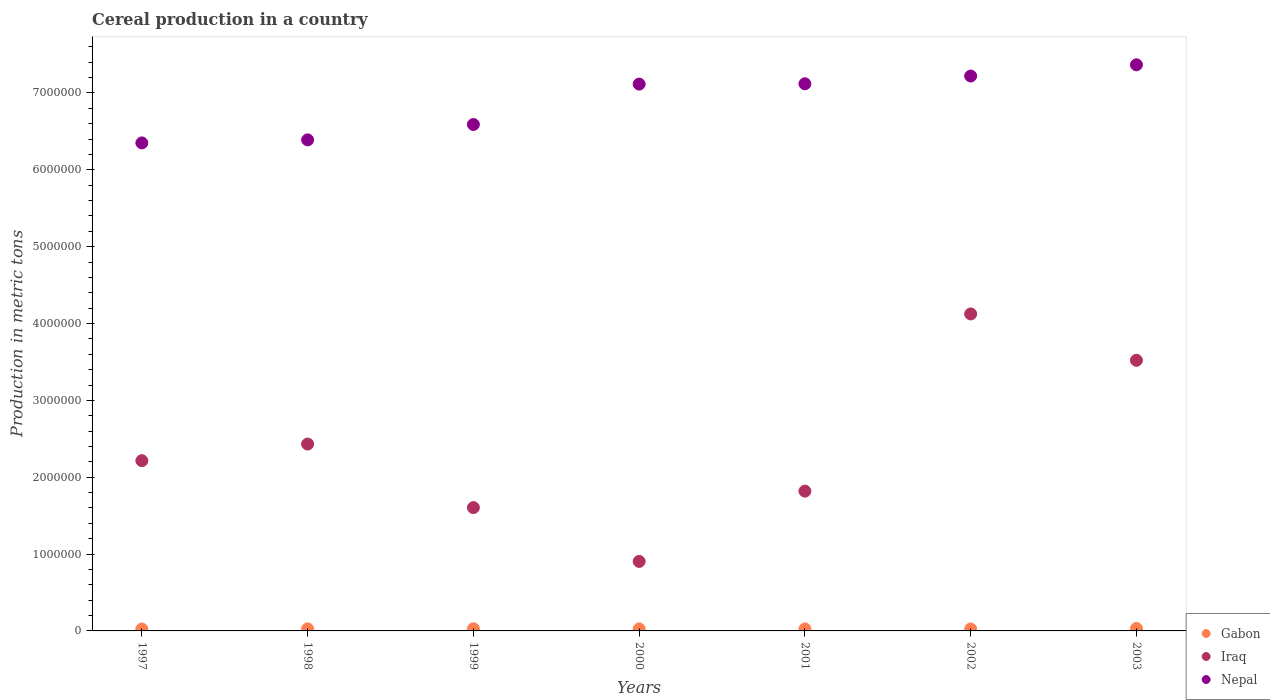Is the number of dotlines equal to the number of legend labels?
Make the answer very short. Yes. What is the total cereal production in Gabon in 2001?
Offer a very short reply. 2.61e+04. Across all years, what is the maximum total cereal production in Gabon?
Offer a very short reply. 3.22e+04. Across all years, what is the minimum total cereal production in Gabon?
Keep it short and to the point. 2.46e+04. In which year was the total cereal production in Nepal maximum?
Your response must be concise. 2003. In which year was the total cereal production in Iraq minimum?
Give a very brief answer. 2000. What is the total total cereal production in Iraq in the graph?
Make the answer very short. 1.66e+07. What is the difference between the total cereal production in Gabon in 2000 and that in 2002?
Offer a terse response. 1973. What is the difference between the total cereal production in Gabon in 2002 and the total cereal production in Nepal in 2001?
Provide a short and direct response. -7.10e+06. What is the average total cereal production in Gabon per year?
Ensure brevity in your answer.  2.70e+04. In the year 1998, what is the difference between the total cereal production in Gabon and total cereal production in Iraq?
Give a very brief answer. -2.40e+06. What is the ratio of the total cereal production in Nepal in 1999 to that in 2000?
Keep it short and to the point. 0.93. What is the difference between the highest and the second highest total cereal production in Nepal?
Ensure brevity in your answer.  1.46e+05. What is the difference between the highest and the lowest total cereal production in Nepal?
Your answer should be compact. 1.02e+06. Is the sum of the total cereal production in Nepal in 1997 and 2001 greater than the maximum total cereal production in Iraq across all years?
Make the answer very short. Yes. Is the total cereal production in Nepal strictly less than the total cereal production in Iraq over the years?
Provide a succinct answer. No. How many dotlines are there?
Offer a very short reply. 3. Are the values on the major ticks of Y-axis written in scientific E-notation?
Provide a succinct answer. No. Does the graph contain any zero values?
Offer a very short reply. No. How many legend labels are there?
Ensure brevity in your answer.  3. What is the title of the graph?
Offer a very short reply. Cereal production in a country. What is the label or title of the Y-axis?
Provide a short and direct response. Production in metric tons. What is the Production in metric tons of Gabon in 1997?
Ensure brevity in your answer.  2.46e+04. What is the Production in metric tons of Iraq in 1997?
Your answer should be very brief. 2.22e+06. What is the Production in metric tons of Nepal in 1997?
Offer a terse response. 6.35e+06. What is the Production in metric tons in Gabon in 1998?
Keep it short and to the point. 2.69e+04. What is the Production in metric tons in Iraq in 1998?
Make the answer very short. 2.43e+06. What is the Production in metric tons in Nepal in 1998?
Provide a succinct answer. 6.39e+06. What is the Production in metric tons in Gabon in 1999?
Offer a very short reply. 2.75e+04. What is the Production in metric tons of Iraq in 1999?
Your response must be concise. 1.60e+06. What is the Production in metric tons of Nepal in 1999?
Your answer should be very brief. 6.59e+06. What is the Production in metric tons in Gabon in 2000?
Your answer should be compact. 2.69e+04. What is the Production in metric tons of Iraq in 2000?
Your answer should be compact. 9.04e+05. What is the Production in metric tons in Nepal in 2000?
Provide a succinct answer. 7.12e+06. What is the Production in metric tons in Gabon in 2001?
Offer a terse response. 2.61e+04. What is the Production in metric tons in Iraq in 2001?
Provide a short and direct response. 1.82e+06. What is the Production in metric tons in Nepal in 2001?
Your response must be concise. 7.12e+06. What is the Production in metric tons in Gabon in 2002?
Keep it short and to the point. 2.49e+04. What is the Production in metric tons in Iraq in 2002?
Give a very brief answer. 4.12e+06. What is the Production in metric tons of Nepal in 2002?
Provide a short and direct response. 7.22e+06. What is the Production in metric tons in Gabon in 2003?
Offer a terse response. 3.22e+04. What is the Production in metric tons in Iraq in 2003?
Provide a short and direct response. 3.52e+06. What is the Production in metric tons of Nepal in 2003?
Make the answer very short. 7.37e+06. Across all years, what is the maximum Production in metric tons in Gabon?
Make the answer very short. 3.22e+04. Across all years, what is the maximum Production in metric tons of Iraq?
Ensure brevity in your answer.  4.12e+06. Across all years, what is the maximum Production in metric tons of Nepal?
Offer a terse response. 7.37e+06. Across all years, what is the minimum Production in metric tons in Gabon?
Offer a terse response. 2.46e+04. Across all years, what is the minimum Production in metric tons in Iraq?
Make the answer very short. 9.04e+05. Across all years, what is the minimum Production in metric tons of Nepal?
Make the answer very short. 6.35e+06. What is the total Production in metric tons in Gabon in the graph?
Offer a very short reply. 1.89e+05. What is the total Production in metric tons of Iraq in the graph?
Your response must be concise. 1.66e+07. What is the total Production in metric tons in Nepal in the graph?
Keep it short and to the point. 4.82e+07. What is the difference between the Production in metric tons of Gabon in 1997 and that in 1998?
Offer a terse response. -2259. What is the difference between the Production in metric tons of Iraq in 1997 and that in 1998?
Ensure brevity in your answer.  -2.16e+05. What is the difference between the Production in metric tons of Nepal in 1997 and that in 1998?
Keep it short and to the point. -3.96e+04. What is the difference between the Production in metric tons in Gabon in 1997 and that in 1999?
Provide a short and direct response. -2875. What is the difference between the Production in metric tons of Iraq in 1997 and that in 1999?
Your answer should be compact. 6.11e+05. What is the difference between the Production in metric tons of Nepal in 1997 and that in 1999?
Your answer should be compact. -2.40e+05. What is the difference between the Production in metric tons of Gabon in 1997 and that in 2000?
Your answer should be compact. -2254. What is the difference between the Production in metric tons in Iraq in 1997 and that in 2000?
Give a very brief answer. 1.31e+06. What is the difference between the Production in metric tons in Nepal in 1997 and that in 2000?
Make the answer very short. -7.65e+05. What is the difference between the Production in metric tons in Gabon in 1997 and that in 2001?
Provide a short and direct response. -1475. What is the difference between the Production in metric tons in Iraq in 1997 and that in 2001?
Your answer should be compact. 3.97e+05. What is the difference between the Production in metric tons of Nepal in 1997 and that in 2001?
Ensure brevity in your answer.  -7.70e+05. What is the difference between the Production in metric tons of Gabon in 1997 and that in 2002?
Make the answer very short. -281. What is the difference between the Production in metric tons of Iraq in 1997 and that in 2002?
Your answer should be compact. -1.91e+06. What is the difference between the Production in metric tons of Nepal in 1997 and that in 2002?
Provide a succinct answer. -8.70e+05. What is the difference between the Production in metric tons in Gabon in 1997 and that in 2003?
Ensure brevity in your answer.  -7551. What is the difference between the Production in metric tons of Iraq in 1997 and that in 2003?
Your answer should be very brief. -1.31e+06. What is the difference between the Production in metric tons of Nepal in 1997 and that in 2003?
Ensure brevity in your answer.  -1.02e+06. What is the difference between the Production in metric tons of Gabon in 1998 and that in 1999?
Offer a terse response. -616. What is the difference between the Production in metric tons of Iraq in 1998 and that in 1999?
Offer a terse response. 8.27e+05. What is the difference between the Production in metric tons in Nepal in 1998 and that in 1999?
Keep it short and to the point. -2.00e+05. What is the difference between the Production in metric tons in Iraq in 1998 and that in 2000?
Ensure brevity in your answer.  1.53e+06. What is the difference between the Production in metric tons in Nepal in 1998 and that in 2000?
Offer a very short reply. -7.26e+05. What is the difference between the Production in metric tons of Gabon in 1998 and that in 2001?
Provide a succinct answer. 784. What is the difference between the Production in metric tons in Iraq in 1998 and that in 2001?
Ensure brevity in your answer.  6.13e+05. What is the difference between the Production in metric tons of Nepal in 1998 and that in 2001?
Provide a short and direct response. -7.30e+05. What is the difference between the Production in metric tons in Gabon in 1998 and that in 2002?
Ensure brevity in your answer.  1978. What is the difference between the Production in metric tons of Iraq in 1998 and that in 2002?
Offer a very short reply. -1.69e+06. What is the difference between the Production in metric tons in Nepal in 1998 and that in 2002?
Keep it short and to the point. -8.31e+05. What is the difference between the Production in metric tons in Gabon in 1998 and that in 2003?
Offer a very short reply. -5292. What is the difference between the Production in metric tons of Iraq in 1998 and that in 2003?
Ensure brevity in your answer.  -1.09e+06. What is the difference between the Production in metric tons in Nepal in 1998 and that in 2003?
Provide a succinct answer. -9.77e+05. What is the difference between the Production in metric tons in Gabon in 1999 and that in 2000?
Provide a short and direct response. 621. What is the difference between the Production in metric tons in Iraq in 1999 and that in 2000?
Your response must be concise. 7.00e+05. What is the difference between the Production in metric tons of Nepal in 1999 and that in 2000?
Your answer should be compact. -5.26e+05. What is the difference between the Production in metric tons of Gabon in 1999 and that in 2001?
Ensure brevity in your answer.  1400. What is the difference between the Production in metric tons of Iraq in 1999 and that in 2001?
Offer a terse response. -2.14e+05. What is the difference between the Production in metric tons in Nepal in 1999 and that in 2001?
Ensure brevity in your answer.  -5.30e+05. What is the difference between the Production in metric tons of Gabon in 1999 and that in 2002?
Your answer should be compact. 2594. What is the difference between the Production in metric tons in Iraq in 1999 and that in 2002?
Your response must be concise. -2.52e+06. What is the difference between the Production in metric tons of Nepal in 1999 and that in 2002?
Your response must be concise. -6.31e+05. What is the difference between the Production in metric tons in Gabon in 1999 and that in 2003?
Your answer should be very brief. -4676. What is the difference between the Production in metric tons of Iraq in 1999 and that in 2003?
Make the answer very short. -1.92e+06. What is the difference between the Production in metric tons of Nepal in 1999 and that in 2003?
Keep it short and to the point. -7.77e+05. What is the difference between the Production in metric tons in Gabon in 2000 and that in 2001?
Provide a short and direct response. 779. What is the difference between the Production in metric tons of Iraq in 2000 and that in 2001?
Offer a very short reply. -9.15e+05. What is the difference between the Production in metric tons of Nepal in 2000 and that in 2001?
Your response must be concise. -4417. What is the difference between the Production in metric tons of Gabon in 2000 and that in 2002?
Ensure brevity in your answer.  1973. What is the difference between the Production in metric tons of Iraq in 2000 and that in 2002?
Offer a very short reply. -3.22e+06. What is the difference between the Production in metric tons in Nepal in 2000 and that in 2002?
Provide a succinct answer. -1.05e+05. What is the difference between the Production in metric tons of Gabon in 2000 and that in 2003?
Offer a terse response. -5297. What is the difference between the Production in metric tons of Iraq in 2000 and that in 2003?
Ensure brevity in your answer.  -2.62e+06. What is the difference between the Production in metric tons in Nepal in 2000 and that in 2003?
Your response must be concise. -2.51e+05. What is the difference between the Production in metric tons of Gabon in 2001 and that in 2002?
Make the answer very short. 1194. What is the difference between the Production in metric tons in Iraq in 2001 and that in 2002?
Ensure brevity in your answer.  -2.31e+06. What is the difference between the Production in metric tons in Nepal in 2001 and that in 2002?
Your response must be concise. -1.01e+05. What is the difference between the Production in metric tons in Gabon in 2001 and that in 2003?
Offer a very short reply. -6076. What is the difference between the Production in metric tons in Iraq in 2001 and that in 2003?
Offer a terse response. -1.70e+06. What is the difference between the Production in metric tons in Nepal in 2001 and that in 2003?
Provide a succinct answer. -2.47e+05. What is the difference between the Production in metric tons in Gabon in 2002 and that in 2003?
Give a very brief answer. -7270. What is the difference between the Production in metric tons of Iraq in 2002 and that in 2003?
Offer a terse response. 6.04e+05. What is the difference between the Production in metric tons in Nepal in 2002 and that in 2003?
Keep it short and to the point. -1.46e+05. What is the difference between the Production in metric tons in Gabon in 1997 and the Production in metric tons in Iraq in 1998?
Your answer should be compact. -2.41e+06. What is the difference between the Production in metric tons in Gabon in 1997 and the Production in metric tons in Nepal in 1998?
Give a very brief answer. -6.37e+06. What is the difference between the Production in metric tons in Iraq in 1997 and the Production in metric tons in Nepal in 1998?
Provide a short and direct response. -4.17e+06. What is the difference between the Production in metric tons in Gabon in 1997 and the Production in metric tons in Iraq in 1999?
Make the answer very short. -1.58e+06. What is the difference between the Production in metric tons of Gabon in 1997 and the Production in metric tons of Nepal in 1999?
Your answer should be very brief. -6.57e+06. What is the difference between the Production in metric tons of Iraq in 1997 and the Production in metric tons of Nepal in 1999?
Offer a very short reply. -4.37e+06. What is the difference between the Production in metric tons of Gabon in 1997 and the Production in metric tons of Iraq in 2000?
Offer a very short reply. -8.80e+05. What is the difference between the Production in metric tons in Gabon in 1997 and the Production in metric tons in Nepal in 2000?
Make the answer very short. -7.09e+06. What is the difference between the Production in metric tons in Iraq in 1997 and the Production in metric tons in Nepal in 2000?
Provide a succinct answer. -4.90e+06. What is the difference between the Production in metric tons in Gabon in 1997 and the Production in metric tons in Iraq in 2001?
Your response must be concise. -1.79e+06. What is the difference between the Production in metric tons in Gabon in 1997 and the Production in metric tons in Nepal in 2001?
Ensure brevity in your answer.  -7.10e+06. What is the difference between the Production in metric tons of Iraq in 1997 and the Production in metric tons of Nepal in 2001?
Your response must be concise. -4.90e+06. What is the difference between the Production in metric tons in Gabon in 1997 and the Production in metric tons in Iraq in 2002?
Provide a short and direct response. -4.10e+06. What is the difference between the Production in metric tons in Gabon in 1997 and the Production in metric tons in Nepal in 2002?
Give a very brief answer. -7.20e+06. What is the difference between the Production in metric tons in Iraq in 1997 and the Production in metric tons in Nepal in 2002?
Offer a terse response. -5.01e+06. What is the difference between the Production in metric tons in Gabon in 1997 and the Production in metric tons in Iraq in 2003?
Ensure brevity in your answer.  -3.50e+06. What is the difference between the Production in metric tons of Gabon in 1997 and the Production in metric tons of Nepal in 2003?
Offer a very short reply. -7.34e+06. What is the difference between the Production in metric tons in Iraq in 1997 and the Production in metric tons in Nepal in 2003?
Provide a short and direct response. -5.15e+06. What is the difference between the Production in metric tons of Gabon in 1998 and the Production in metric tons of Iraq in 1999?
Ensure brevity in your answer.  -1.58e+06. What is the difference between the Production in metric tons of Gabon in 1998 and the Production in metric tons of Nepal in 1999?
Provide a succinct answer. -6.56e+06. What is the difference between the Production in metric tons of Iraq in 1998 and the Production in metric tons of Nepal in 1999?
Your answer should be very brief. -4.16e+06. What is the difference between the Production in metric tons of Gabon in 1998 and the Production in metric tons of Iraq in 2000?
Your answer should be very brief. -8.78e+05. What is the difference between the Production in metric tons of Gabon in 1998 and the Production in metric tons of Nepal in 2000?
Give a very brief answer. -7.09e+06. What is the difference between the Production in metric tons of Iraq in 1998 and the Production in metric tons of Nepal in 2000?
Give a very brief answer. -4.68e+06. What is the difference between the Production in metric tons of Gabon in 1998 and the Production in metric tons of Iraq in 2001?
Keep it short and to the point. -1.79e+06. What is the difference between the Production in metric tons in Gabon in 1998 and the Production in metric tons in Nepal in 2001?
Offer a terse response. -7.09e+06. What is the difference between the Production in metric tons of Iraq in 1998 and the Production in metric tons of Nepal in 2001?
Provide a short and direct response. -4.69e+06. What is the difference between the Production in metric tons of Gabon in 1998 and the Production in metric tons of Iraq in 2002?
Provide a short and direct response. -4.10e+06. What is the difference between the Production in metric tons in Gabon in 1998 and the Production in metric tons in Nepal in 2002?
Your answer should be compact. -7.19e+06. What is the difference between the Production in metric tons of Iraq in 1998 and the Production in metric tons of Nepal in 2002?
Provide a short and direct response. -4.79e+06. What is the difference between the Production in metric tons in Gabon in 1998 and the Production in metric tons in Iraq in 2003?
Make the answer very short. -3.49e+06. What is the difference between the Production in metric tons in Gabon in 1998 and the Production in metric tons in Nepal in 2003?
Your response must be concise. -7.34e+06. What is the difference between the Production in metric tons in Iraq in 1998 and the Production in metric tons in Nepal in 2003?
Provide a short and direct response. -4.94e+06. What is the difference between the Production in metric tons in Gabon in 1999 and the Production in metric tons in Iraq in 2000?
Make the answer very short. -8.77e+05. What is the difference between the Production in metric tons of Gabon in 1999 and the Production in metric tons of Nepal in 2000?
Your answer should be compact. -7.09e+06. What is the difference between the Production in metric tons of Iraq in 1999 and the Production in metric tons of Nepal in 2000?
Give a very brief answer. -5.51e+06. What is the difference between the Production in metric tons in Gabon in 1999 and the Production in metric tons in Iraq in 2001?
Ensure brevity in your answer.  -1.79e+06. What is the difference between the Production in metric tons of Gabon in 1999 and the Production in metric tons of Nepal in 2001?
Provide a short and direct response. -7.09e+06. What is the difference between the Production in metric tons of Iraq in 1999 and the Production in metric tons of Nepal in 2001?
Your answer should be compact. -5.52e+06. What is the difference between the Production in metric tons in Gabon in 1999 and the Production in metric tons in Iraq in 2002?
Provide a short and direct response. -4.10e+06. What is the difference between the Production in metric tons in Gabon in 1999 and the Production in metric tons in Nepal in 2002?
Provide a succinct answer. -7.19e+06. What is the difference between the Production in metric tons of Iraq in 1999 and the Production in metric tons of Nepal in 2002?
Provide a short and direct response. -5.62e+06. What is the difference between the Production in metric tons in Gabon in 1999 and the Production in metric tons in Iraq in 2003?
Keep it short and to the point. -3.49e+06. What is the difference between the Production in metric tons in Gabon in 1999 and the Production in metric tons in Nepal in 2003?
Your answer should be very brief. -7.34e+06. What is the difference between the Production in metric tons in Iraq in 1999 and the Production in metric tons in Nepal in 2003?
Your answer should be compact. -5.76e+06. What is the difference between the Production in metric tons in Gabon in 2000 and the Production in metric tons in Iraq in 2001?
Keep it short and to the point. -1.79e+06. What is the difference between the Production in metric tons in Gabon in 2000 and the Production in metric tons in Nepal in 2001?
Offer a very short reply. -7.09e+06. What is the difference between the Production in metric tons of Iraq in 2000 and the Production in metric tons of Nepal in 2001?
Provide a succinct answer. -6.22e+06. What is the difference between the Production in metric tons of Gabon in 2000 and the Production in metric tons of Iraq in 2002?
Your answer should be compact. -4.10e+06. What is the difference between the Production in metric tons in Gabon in 2000 and the Production in metric tons in Nepal in 2002?
Make the answer very short. -7.19e+06. What is the difference between the Production in metric tons of Iraq in 2000 and the Production in metric tons of Nepal in 2002?
Your answer should be compact. -6.32e+06. What is the difference between the Production in metric tons of Gabon in 2000 and the Production in metric tons of Iraq in 2003?
Provide a succinct answer. -3.49e+06. What is the difference between the Production in metric tons in Gabon in 2000 and the Production in metric tons in Nepal in 2003?
Offer a terse response. -7.34e+06. What is the difference between the Production in metric tons in Iraq in 2000 and the Production in metric tons in Nepal in 2003?
Provide a succinct answer. -6.46e+06. What is the difference between the Production in metric tons in Gabon in 2001 and the Production in metric tons in Iraq in 2002?
Your response must be concise. -4.10e+06. What is the difference between the Production in metric tons in Gabon in 2001 and the Production in metric tons in Nepal in 2002?
Provide a short and direct response. -7.19e+06. What is the difference between the Production in metric tons in Iraq in 2001 and the Production in metric tons in Nepal in 2002?
Your response must be concise. -5.40e+06. What is the difference between the Production in metric tons in Gabon in 2001 and the Production in metric tons in Iraq in 2003?
Your answer should be very brief. -3.50e+06. What is the difference between the Production in metric tons in Gabon in 2001 and the Production in metric tons in Nepal in 2003?
Your answer should be compact. -7.34e+06. What is the difference between the Production in metric tons of Iraq in 2001 and the Production in metric tons of Nepal in 2003?
Give a very brief answer. -5.55e+06. What is the difference between the Production in metric tons of Gabon in 2002 and the Production in metric tons of Iraq in 2003?
Provide a short and direct response. -3.50e+06. What is the difference between the Production in metric tons in Gabon in 2002 and the Production in metric tons in Nepal in 2003?
Give a very brief answer. -7.34e+06. What is the difference between the Production in metric tons in Iraq in 2002 and the Production in metric tons in Nepal in 2003?
Your response must be concise. -3.24e+06. What is the average Production in metric tons in Gabon per year?
Provide a short and direct response. 2.70e+04. What is the average Production in metric tons in Iraq per year?
Offer a terse response. 2.37e+06. What is the average Production in metric tons in Nepal per year?
Offer a terse response. 6.88e+06. In the year 1997, what is the difference between the Production in metric tons in Gabon and Production in metric tons in Iraq?
Provide a succinct answer. -2.19e+06. In the year 1997, what is the difference between the Production in metric tons of Gabon and Production in metric tons of Nepal?
Offer a very short reply. -6.33e+06. In the year 1997, what is the difference between the Production in metric tons of Iraq and Production in metric tons of Nepal?
Your answer should be compact. -4.13e+06. In the year 1998, what is the difference between the Production in metric tons of Gabon and Production in metric tons of Iraq?
Make the answer very short. -2.40e+06. In the year 1998, what is the difference between the Production in metric tons in Gabon and Production in metric tons in Nepal?
Offer a terse response. -6.36e+06. In the year 1998, what is the difference between the Production in metric tons in Iraq and Production in metric tons in Nepal?
Your answer should be compact. -3.96e+06. In the year 1999, what is the difference between the Production in metric tons in Gabon and Production in metric tons in Iraq?
Provide a short and direct response. -1.58e+06. In the year 1999, what is the difference between the Production in metric tons of Gabon and Production in metric tons of Nepal?
Give a very brief answer. -6.56e+06. In the year 1999, what is the difference between the Production in metric tons of Iraq and Production in metric tons of Nepal?
Your answer should be very brief. -4.99e+06. In the year 2000, what is the difference between the Production in metric tons of Gabon and Production in metric tons of Iraq?
Provide a short and direct response. -8.78e+05. In the year 2000, what is the difference between the Production in metric tons in Gabon and Production in metric tons in Nepal?
Ensure brevity in your answer.  -7.09e+06. In the year 2000, what is the difference between the Production in metric tons in Iraq and Production in metric tons in Nepal?
Keep it short and to the point. -6.21e+06. In the year 2001, what is the difference between the Production in metric tons of Gabon and Production in metric tons of Iraq?
Provide a succinct answer. -1.79e+06. In the year 2001, what is the difference between the Production in metric tons of Gabon and Production in metric tons of Nepal?
Your answer should be very brief. -7.09e+06. In the year 2001, what is the difference between the Production in metric tons of Iraq and Production in metric tons of Nepal?
Ensure brevity in your answer.  -5.30e+06. In the year 2002, what is the difference between the Production in metric tons in Gabon and Production in metric tons in Iraq?
Provide a succinct answer. -4.10e+06. In the year 2002, what is the difference between the Production in metric tons of Gabon and Production in metric tons of Nepal?
Keep it short and to the point. -7.20e+06. In the year 2002, what is the difference between the Production in metric tons in Iraq and Production in metric tons in Nepal?
Your response must be concise. -3.10e+06. In the year 2003, what is the difference between the Production in metric tons in Gabon and Production in metric tons in Iraq?
Your answer should be compact. -3.49e+06. In the year 2003, what is the difference between the Production in metric tons in Gabon and Production in metric tons in Nepal?
Your response must be concise. -7.33e+06. In the year 2003, what is the difference between the Production in metric tons in Iraq and Production in metric tons in Nepal?
Keep it short and to the point. -3.85e+06. What is the ratio of the Production in metric tons of Gabon in 1997 to that in 1998?
Make the answer very short. 0.92. What is the ratio of the Production in metric tons of Iraq in 1997 to that in 1998?
Ensure brevity in your answer.  0.91. What is the ratio of the Production in metric tons of Gabon in 1997 to that in 1999?
Keep it short and to the point. 0.9. What is the ratio of the Production in metric tons in Iraq in 1997 to that in 1999?
Ensure brevity in your answer.  1.38. What is the ratio of the Production in metric tons of Nepal in 1997 to that in 1999?
Offer a terse response. 0.96. What is the ratio of the Production in metric tons in Gabon in 1997 to that in 2000?
Your answer should be compact. 0.92. What is the ratio of the Production in metric tons in Iraq in 1997 to that in 2000?
Offer a terse response. 2.45. What is the ratio of the Production in metric tons in Nepal in 1997 to that in 2000?
Provide a succinct answer. 0.89. What is the ratio of the Production in metric tons in Gabon in 1997 to that in 2001?
Your answer should be very brief. 0.94. What is the ratio of the Production in metric tons in Iraq in 1997 to that in 2001?
Ensure brevity in your answer.  1.22. What is the ratio of the Production in metric tons of Nepal in 1997 to that in 2001?
Offer a terse response. 0.89. What is the ratio of the Production in metric tons of Gabon in 1997 to that in 2002?
Provide a short and direct response. 0.99. What is the ratio of the Production in metric tons of Iraq in 1997 to that in 2002?
Provide a short and direct response. 0.54. What is the ratio of the Production in metric tons in Nepal in 1997 to that in 2002?
Offer a very short reply. 0.88. What is the ratio of the Production in metric tons of Gabon in 1997 to that in 2003?
Offer a terse response. 0.77. What is the ratio of the Production in metric tons of Iraq in 1997 to that in 2003?
Provide a succinct answer. 0.63. What is the ratio of the Production in metric tons of Nepal in 1997 to that in 2003?
Provide a succinct answer. 0.86. What is the ratio of the Production in metric tons in Gabon in 1998 to that in 1999?
Your answer should be very brief. 0.98. What is the ratio of the Production in metric tons in Iraq in 1998 to that in 1999?
Offer a very short reply. 1.52. What is the ratio of the Production in metric tons of Nepal in 1998 to that in 1999?
Keep it short and to the point. 0.97. What is the ratio of the Production in metric tons in Iraq in 1998 to that in 2000?
Your answer should be compact. 2.69. What is the ratio of the Production in metric tons in Nepal in 1998 to that in 2000?
Give a very brief answer. 0.9. What is the ratio of the Production in metric tons in Iraq in 1998 to that in 2001?
Keep it short and to the point. 1.34. What is the ratio of the Production in metric tons of Nepal in 1998 to that in 2001?
Ensure brevity in your answer.  0.9. What is the ratio of the Production in metric tons of Gabon in 1998 to that in 2002?
Your response must be concise. 1.08. What is the ratio of the Production in metric tons of Iraq in 1998 to that in 2002?
Your response must be concise. 0.59. What is the ratio of the Production in metric tons in Nepal in 1998 to that in 2002?
Offer a very short reply. 0.88. What is the ratio of the Production in metric tons in Gabon in 1998 to that in 2003?
Give a very brief answer. 0.84. What is the ratio of the Production in metric tons of Iraq in 1998 to that in 2003?
Your answer should be compact. 0.69. What is the ratio of the Production in metric tons in Nepal in 1998 to that in 2003?
Offer a terse response. 0.87. What is the ratio of the Production in metric tons of Gabon in 1999 to that in 2000?
Provide a succinct answer. 1.02. What is the ratio of the Production in metric tons of Iraq in 1999 to that in 2000?
Ensure brevity in your answer.  1.77. What is the ratio of the Production in metric tons in Nepal in 1999 to that in 2000?
Offer a terse response. 0.93. What is the ratio of the Production in metric tons of Gabon in 1999 to that in 2001?
Your response must be concise. 1.05. What is the ratio of the Production in metric tons of Iraq in 1999 to that in 2001?
Give a very brief answer. 0.88. What is the ratio of the Production in metric tons of Nepal in 1999 to that in 2001?
Keep it short and to the point. 0.93. What is the ratio of the Production in metric tons of Gabon in 1999 to that in 2002?
Keep it short and to the point. 1.1. What is the ratio of the Production in metric tons in Iraq in 1999 to that in 2002?
Make the answer very short. 0.39. What is the ratio of the Production in metric tons in Nepal in 1999 to that in 2002?
Your response must be concise. 0.91. What is the ratio of the Production in metric tons of Gabon in 1999 to that in 2003?
Offer a terse response. 0.85. What is the ratio of the Production in metric tons of Iraq in 1999 to that in 2003?
Give a very brief answer. 0.46. What is the ratio of the Production in metric tons in Nepal in 1999 to that in 2003?
Your response must be concise. 0.89. What is the ratio of the Production in metric tons in Gabon in 2000 to that in 2001?
Your answer should be very brief. 1.03. What is the ratio of the Production in metric tons of Iraq in 2000 to that in 2001?
Your answer should be very brief. 0.5. What is the ratio of the Production in metric tons in Nepal in 2000 to that in 2001?
Your answer should be very brief. 1. What is the ratio of the Production in metric tons of Gabon in 2000 to that in 2002?
Offer a terse response. 1.08. What is the ratio of the Production in metric tons of Iraq in 2000 to that in 2002?
Offer a very short reply. 0.22. What is the ratio of the Production in metric tons of Nepal in 2000 to that in 2002?
Your answer should be compact. 0.99. What is the ratio of the Production in metric tons of Gabon in 2000 to that in 2003?
Give a very brief answer. 0.84. What is the ratio of the Production in metric tons of Iraq in 2000 to that in 2003?
Your answer should be compact. 0.26. What is the ratio of the Production in metric tons in Nepal in 2000 to that in 2003?
Give a very brief answer. 0.97. What is the ratio of the Production in metric tons of Gabon in 2001 to that in 2002?
Your answer should be compact. 1.05. What is the ratio of the Production in metric tons in Iraq in 2001 to that in 2002?
Your answer should be compact. 0.44. What is the ratio of the Production in metric tons in Gabon in 2001 to that in 2003?
Keep it short and to the point. 0.81. What is the ratio of the Production in metric tons in Iraq in 2001 to that in 2003?
Offer a very short reply. 0.52. What is the ratio of the Production in metric tons in Nepal in 2001 to that in 2003?
Offer a terse response. 0.97. What is the ratio of the Production in metric tons of Gabon in 2002 to that in 2003?
Offer a very short reply. 0.77. What is the ratio of the Production in metric tons in Iraq in 2002 to that in 2003?
Make the answer very short. 1.17. What is the ratio of the Production in metric tons of Nepal in 2002 to that in 2003?
Keep it short and to the point. 0.98. What is the difference between the highest and the second highest Production in metric tons of Gabon?
Provide a short and direct response. 4676. What is the difference between the highest and the second highest Production in metric tons of Iraq?
Ensure brevity in your answer.  6.04e+05. What is the difference between the highest and the second highest Production in metric tons in Nepal?
Provide a short and direct response. 1.46e+05. What is the difference between the highest and the lowest Production in metric tons of Gabon?
Your answer should be compact. 7551. What is the difference between the highest and the lowest Production in metric tons in Iraq?
Offer a terse response. 3.22e+06. What is the difference between the highest and the lowest Production in metric tons in Nepal?
Your answer should be very brief. 1.02e+06. 